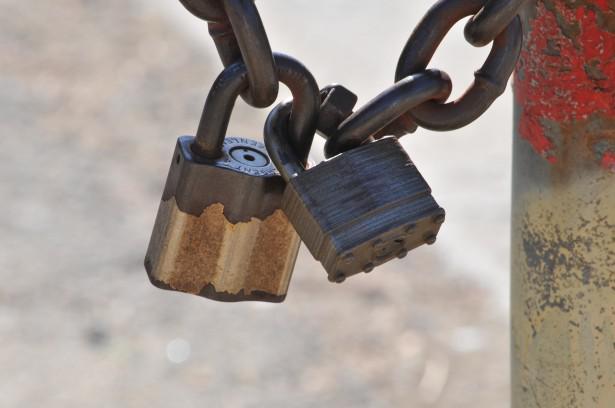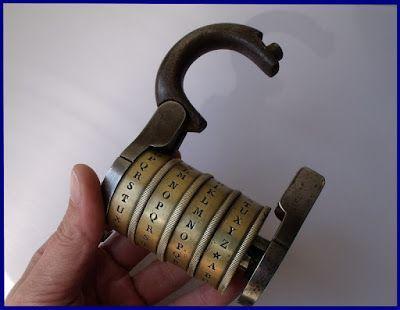The first image is the image on the left, the second image is the image on the right. Assess this claim about the two images: "There are two separate keys inserted into the locks.". Correct or not? Answer yes or no. No. The first image is the image on the left, the second image is the image on the right. Assess this claim about the two images: "The right image has at least two keys.". Correct or not? Answer yes or no. No. 